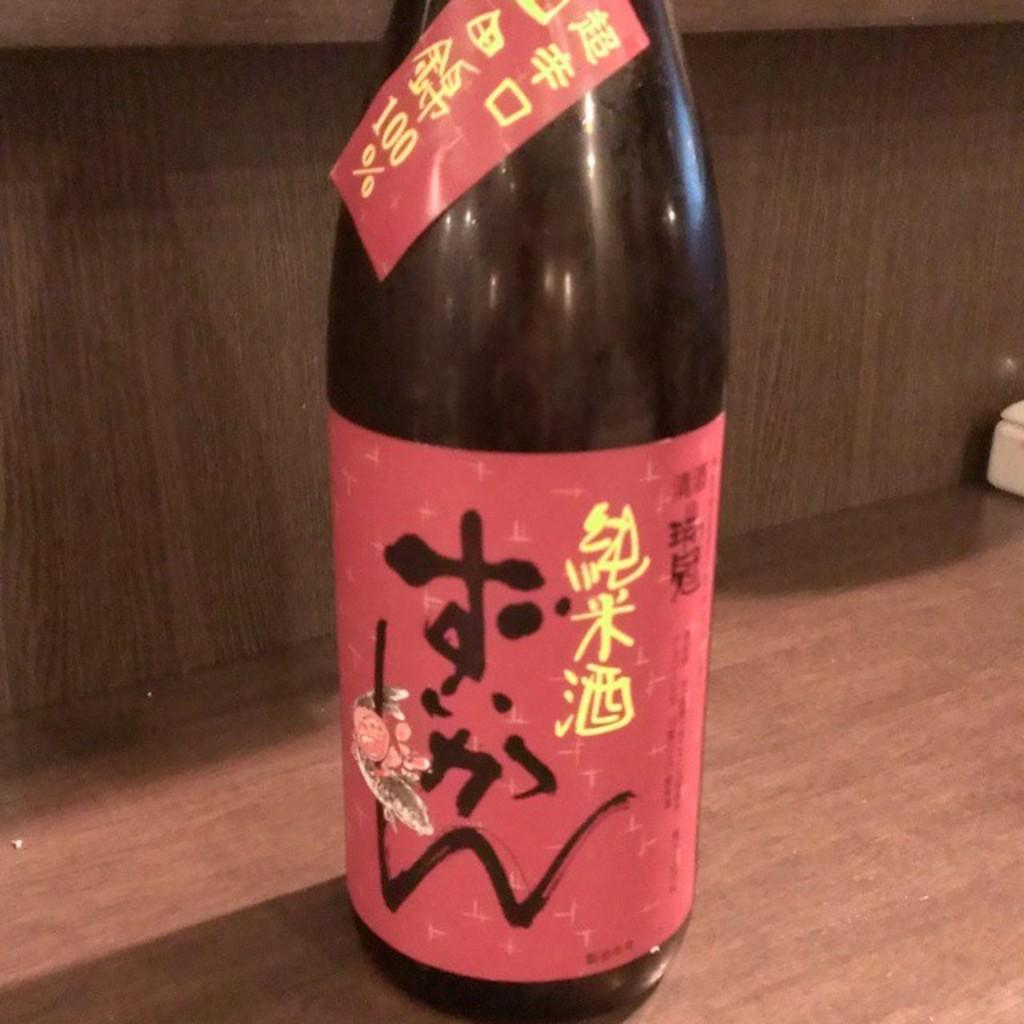Provide a one-sentence caption for the provided image. A foreign beer bottle that has the percentage of 100 on it. 